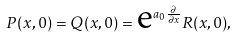Convert formula to latex. <formula><loc_0><loc_0><loc_500><loc_500>P ( x , 0 ) = Q ( x , 0 ) = \text {e} ^ { a _ { 0 } \frac { \partial } { \partial x } } R ( x , 0 ) ,</formula> 